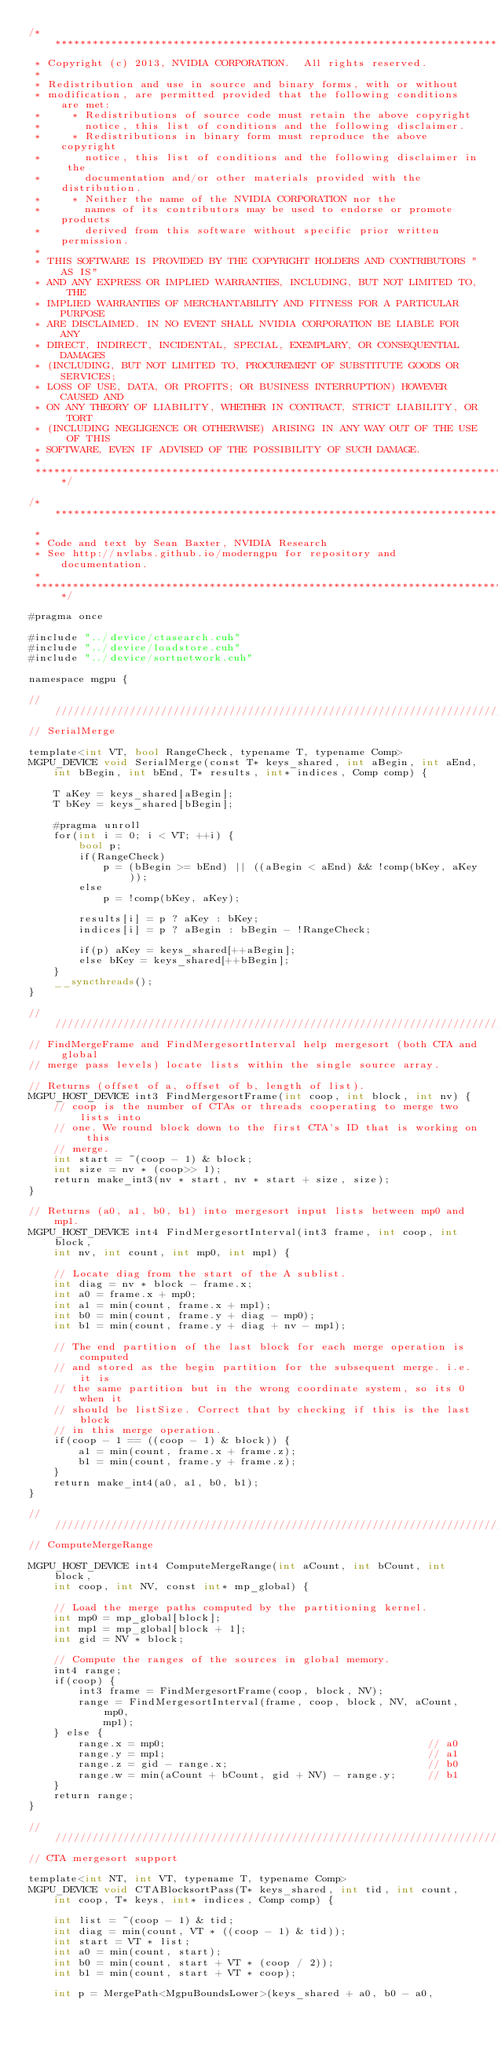<code> <loc_0><loc_0><loc_500><loc_500><_Cuda_>/******************************************************************************
 * Copyright (c) 2013, NVIDIA CORPORATION.  All rights reserved.
 * 
 * Redistribution and use in source and binary forms, with or without
 * modification, are permitted provided that the following conditions are met:
 *     * Redistributions of source code must retain the above copyright
 *       notice, this list of conditions and the following disclaimer.
 *     * Redistributions in binary form must reproduce the above copyright
 *       notice, this list of conditions and the following disclaimer in the
 *       documentation and/or other materials provided with the distribution.
 *     * Neither the name of the NVIDIA CORPORATION nor the
 *       names of its contributors may be used to endorse or promote products
 *       derived from this software without specific prior written permission.
 * 
 * THIS SOFTWARE IS PROVIDED BY THE COPYRIGHT HOLDERS AND CONTRIBUTORS "AS IS" 
 * AND ANY EXPRESS OR IMPLIED WARRANTIES, INCLUDING, BUT NOT LIMITED TO, THE
 * IMPLIED WARRANTIES OF MERCHANTABILITY AND FITNESS FOR A PARTICULAR PURPOSE 
 * ARE DISCLAIMED. IN NO EVENT SHALL NVIDIA CORPORATION BE LIABLE FOR ANY
 * DIRECT, INDIRECT, INCIDENTAL, SPECIAL, EXEMPLARY, OR CONSEQUENTIAL DAMAGES
 * (INCLUDING, BUT NOT LIMITED TO, PROCUREMENT OF SUBSTITUTE GOODS OR SERVICES;
 * LOSS OF USE, DATA, OR PROFITS; OR BUSINESS INTERRUPTION) HOWEVER CAUSED AND
 * ON ANY THEORY OF LIABILITY, WHETHER IN CONTRACT, STRICT LIABILITY, OR TORT
 * (INCLUDING NEGLIGENCE OR OTHERWISE) ARISING IN ANY WAY OUT OF THE USE OF THIS
 * SOFTWARE, EVEN IF ADVISED OF THE POSSIBILITY OF SUCH DAMAGE.
 *
 ******************************************************************************/

/******************************************************************************
 *
 * Code and text by Sean Baxter, NVIDIA Research
 * See http://nvlabs.github.io/moderngpu for repository and documentation.
 *
 ******************************************************************************/

#pragma once

#include "../device/ctasearch.cuh"
#include "../device/loadstore.cuh"
#include "../device/sortnetwork.cuh"

namespace mgpu {

////////////////////////////////////////////////////////////////////////////////
// SerialMerge
	
template<int VT, bool RangeCheck, typename T, typename Comp>
MGPU_DEVICE void SerialMerge(const T* keys_shared, int aBegin, int aEnd,
	int bBegin, int bEnd, T* results, int* indices, Comp comp) { 

	T aKey = keys_shared[aBegin];
	T bKey = keys_shared[bBegin];

	#pragma unroll
	for(int i = 0; i < VT; ++i) {
		bool p;
		if(RangeCheck) 
			p = (bBegin >= bEnd) || ((aBegin < aEnd) && !comp(bKey, aKey));
		else
			p = !comp(bKey, aKey);

		results[i] = p ? aKey : bKey;
		indices[i] = p ? aBegin : bBegin - !RangeCheck;

		if(p) aKey = keys_shared[++aBegin];
		else bKey = keys_shared[++bBegin];
	}
	__syncthreads();
}

////////////////////////////////////////////////////////////////////////////////
// FindMergeFrame and FindMergesortInterval help mergesort (both CTA and global 
// merge pass levels) locate lists within the single source array.

// Returns (offset of a, offset of b, length of list).
MGPU_HOST_DEVICE int3 FindMergesortFrame(int coop, int block, int nv) {
	// coop is the number of CTAs or threads cooperating to merge two lists into
	// one. We round block down to the first CTA's ID that is working on this
	// merge.
	int start = ~(coop - 1) & block;
	int size = nv * (coop>> 1);
	return make_int3(nv * start, nv * start + size, size);
}

// Returns (a0, a1, b0, b1) into mergesort input lists between mp0 and mp1.
MGPU_HOST_DEVICE int4 FindMergesortInterval(int3 frame, int coop, int block,
	int nv, int count, int mp0, int mp1) {

	// Locate diag from the start of the A sublist.
	int diag = nv * block - frame.x;
	int a0 = frame.x + mp0;
	int a1 = min(count, frame.x + mp1);
	int b0 = min(count, frame.y + diag - mp0);
	int b1 = min(count, frame.y + diag + nv - mp1);
	
	// The end partition of the last block for each merge operation is computed
	// and stored as the begin partition for the subsequent merge. i.e. it is
	// the same partition but in the wrong coordinate system, so its 0 when it
	// should be listSize. Correct that by checking if this is the last block
	// in this merge operation.
	if(coop - 1 == ((coop - 1) & block)) {
		a1 = min(count, frame.x + frame.z);
		b1 = min(count, frame.y + frame.z);
	}
	return make_int4(a0, a1, b0, b1);
}

////////////////////////////////////////////////////////////////////////////////
// ComputeMergeRange

MGPU_HOST_DEVICE int4 ComputeMergeRange(int aCount, int bCount, int block, 
	int coop, int NV, const int* mp_global) {

	// Load the merge paths computed by the partitioning kernel.
	int mp0 = mp_global[block];
	int mp1 = mp_global[block + 1];
	int gid = NV * block;

	// Compute the ranges of the sources in global memory.
	int4 range;
	if(coop) {
		int3 frame = FindMergesortFrame(coop, block, NV);
		range = FindMergesortInterval(frame, coop, block, NV, aCount, mp0, 
			mp1);
	} else {
		range.x = mp0;											// a0
		range.y = mp1;											// a1
		range.z = gid - range.x;								// b0
		range.w = min(aCount + bCount, gid + NV) - range.y;		// b1
	}
	return range;
}

////////////////////////////////////////////////////////////////////////////////
// CTA mergesort support

template<int NT, int VT, typename T, typename Comp>
MGPU_DEVICE void CTABlocksortPass(T* keys_shared, int tid, int count,
	int coop, T* keys, int* indices, Comp comp) {

	int list = ~(coop - 1) & tid;
	int diag = min(count, VT * ((coop - 1) & tid));
	int start = VT * list;
	int a0 = min(count, start);
	int b0 = min(count, start + VT * (coop / 2));
	int b1 = min(count, start + VT * coop);

	int p = MergePath<MgpuBoundsLower>(keys_shared + a0, b0 - a0,</code> 